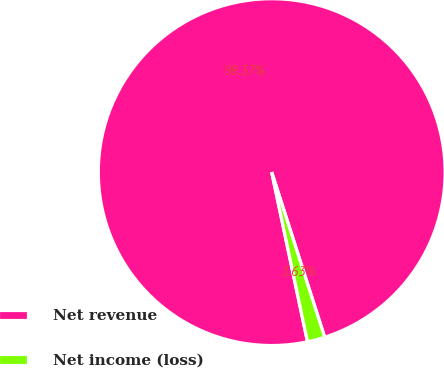Convert chart. <chart><loc_0><loc_0><loc_500><loc_500><pie_chart><fcel>Net revenue<fcel>Net income (loss)<nl><fcel>98.37%<fcel>1.63%<nl></chart> 